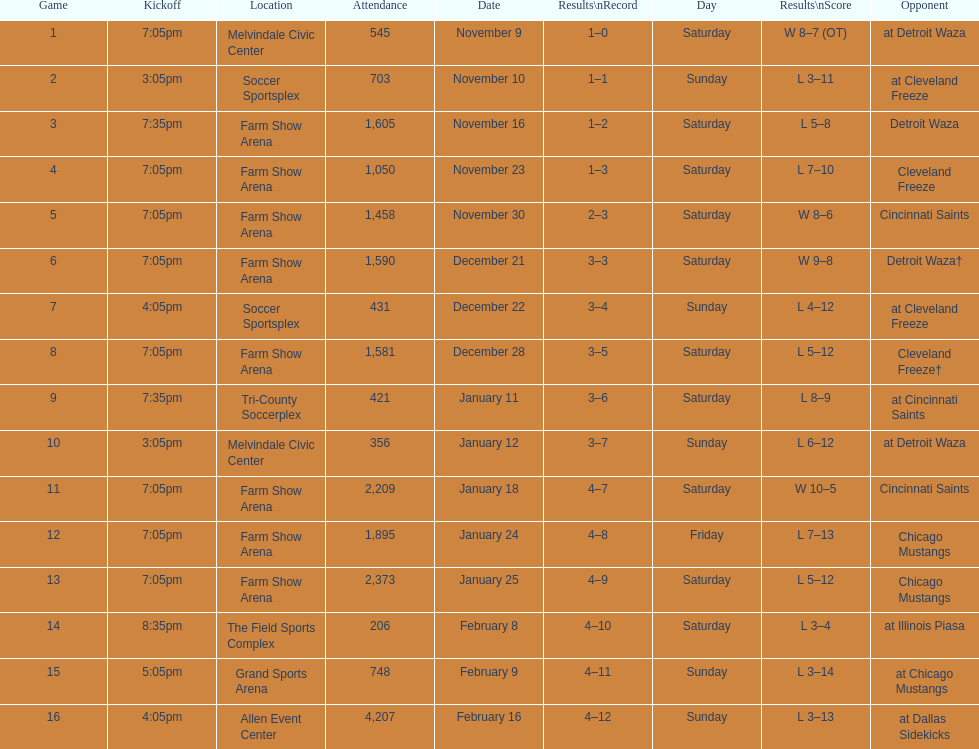In total, how many games were lost by the harrisburg heat to the cleveland freeze? 4. 